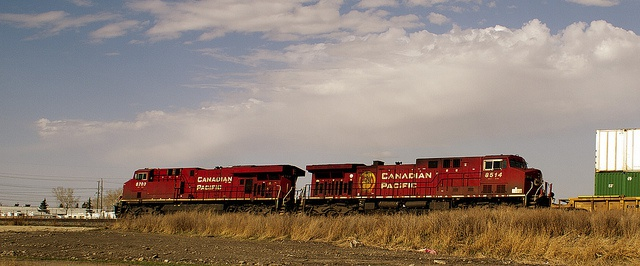Describe the objects in this image and their specific colors. I can see a train in gray, black, maroon, and darkgray tones in this image. 